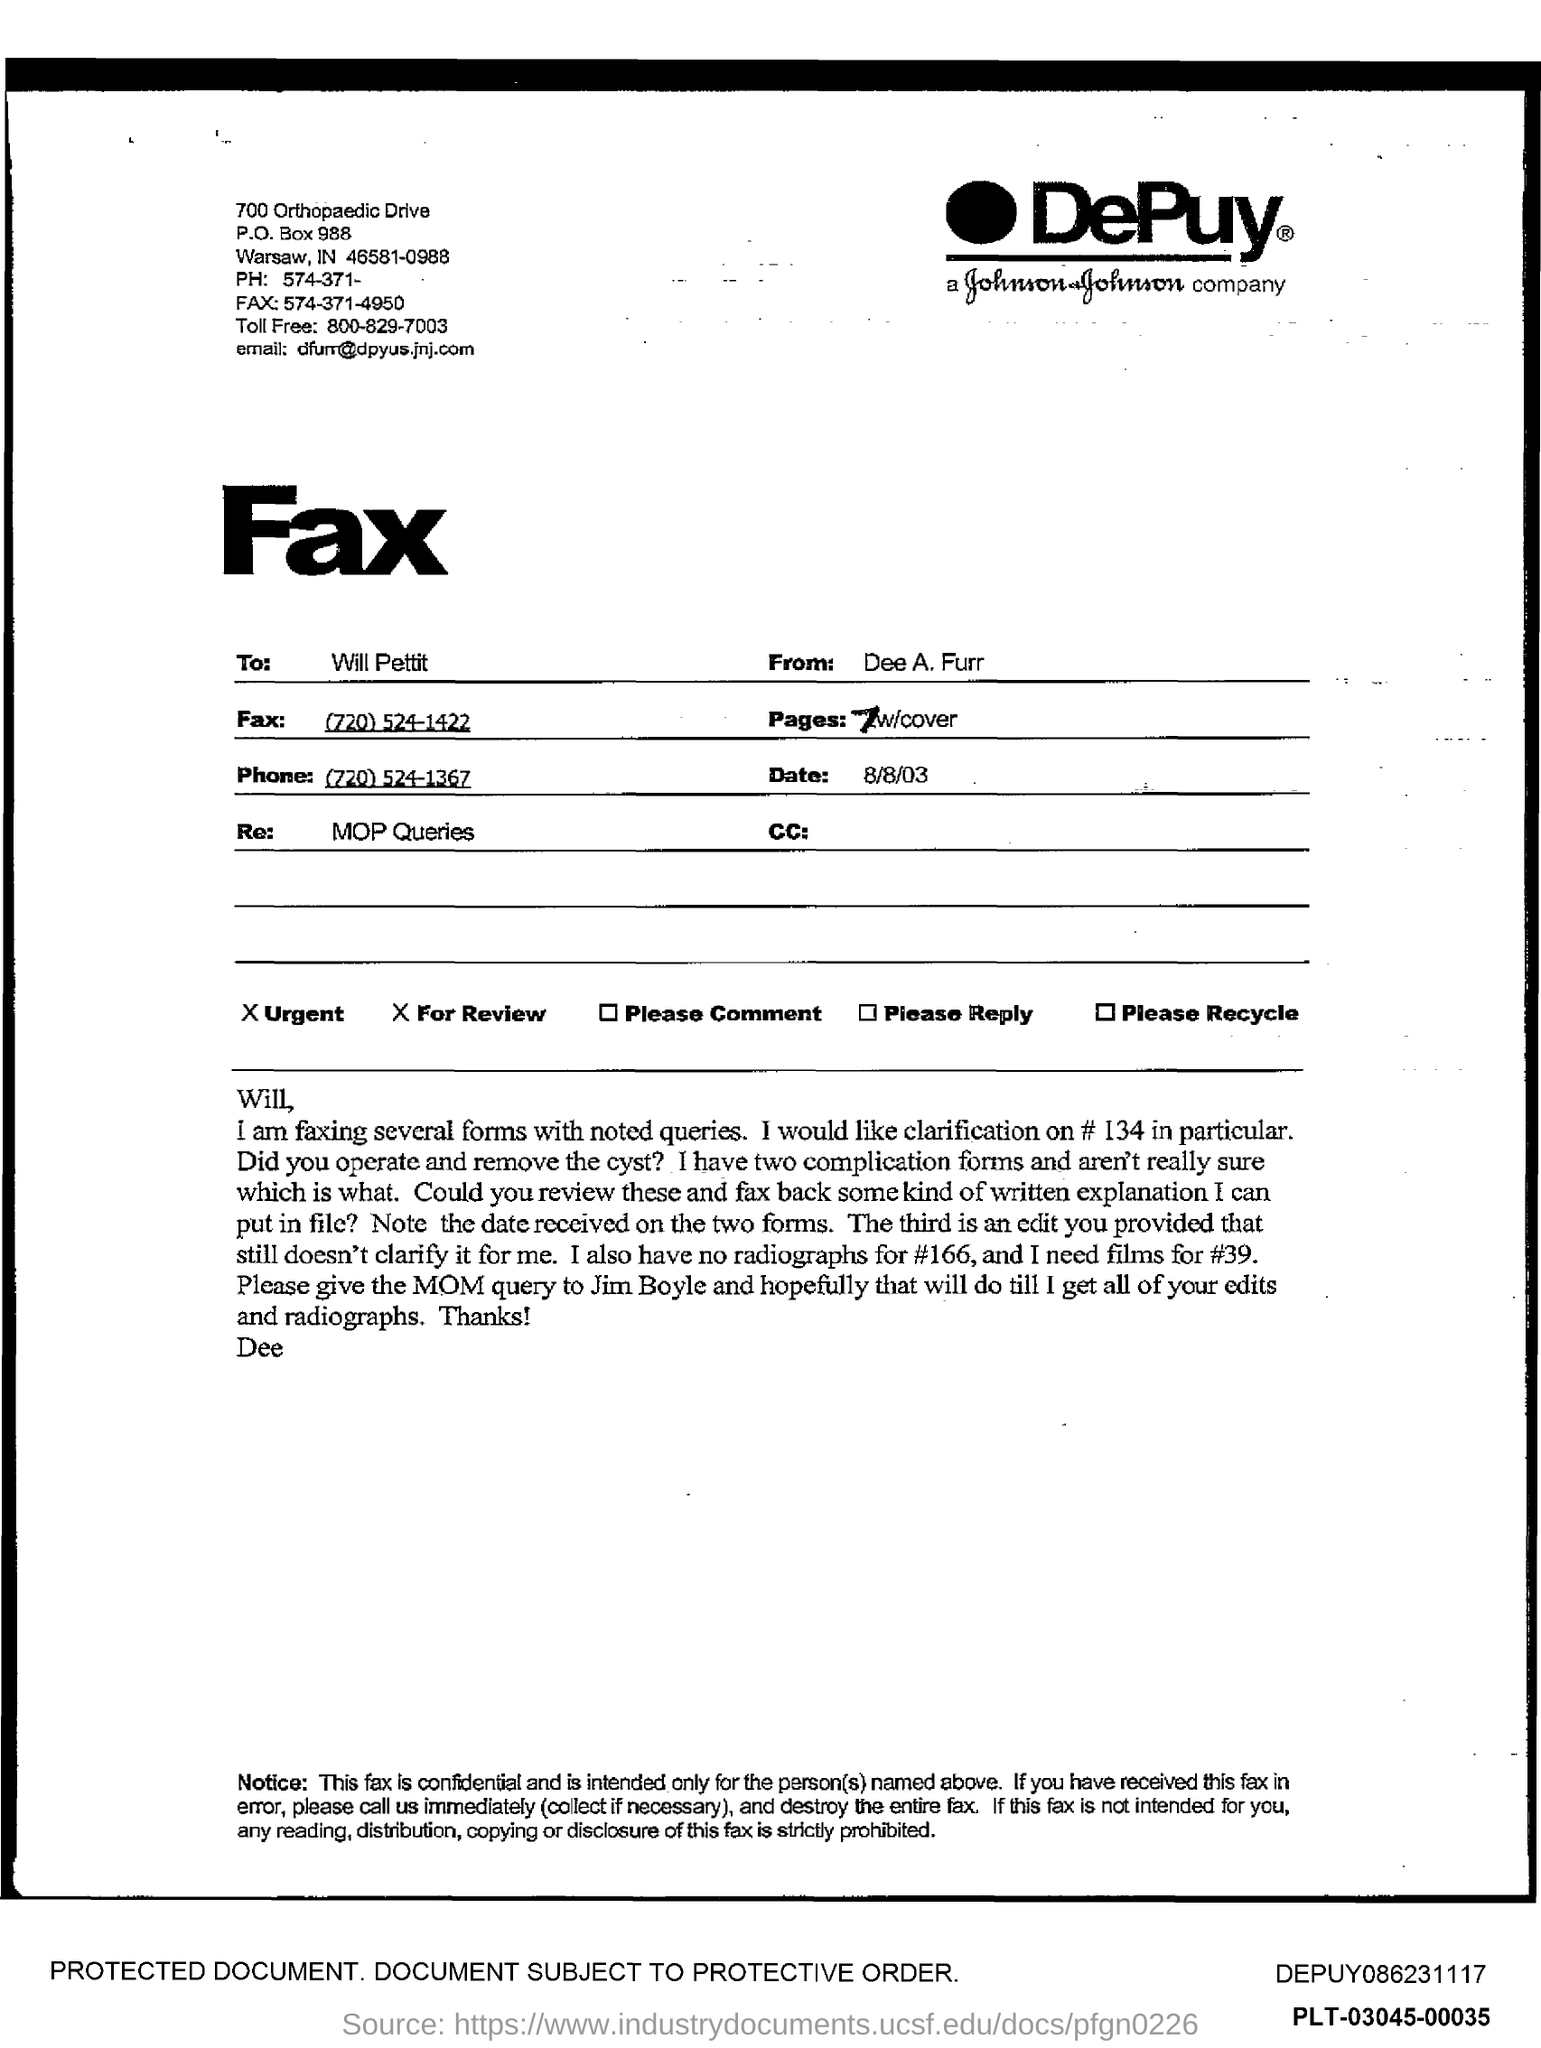Who is this Fax from?
 Dee A. Furr 